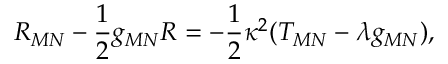Convert formula to latex. <formula><loc_0><loc_0><loc_500><loc_500>R _ { M N } - \frac { 1 } { 2 } g _ { M N } R = - \frac { 1 } { 2 } \kappa ^ { 2 } ( T _ { M N } - \lambda g _ { M N } ) ,</formula> 